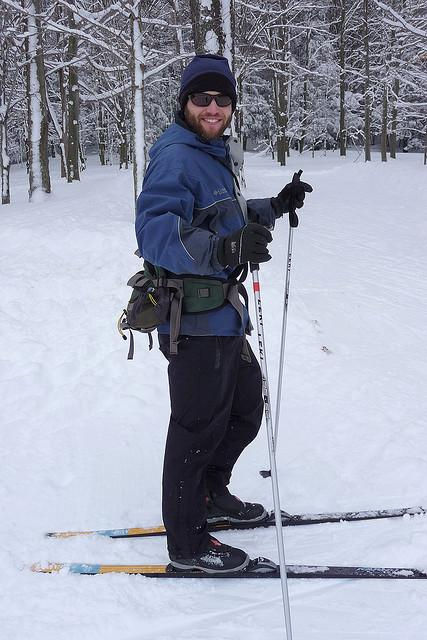What type of skiing is he likely doing?

Choices:
A) slalom
B) downhill
C) trick
D) crosscountry crosscountry 